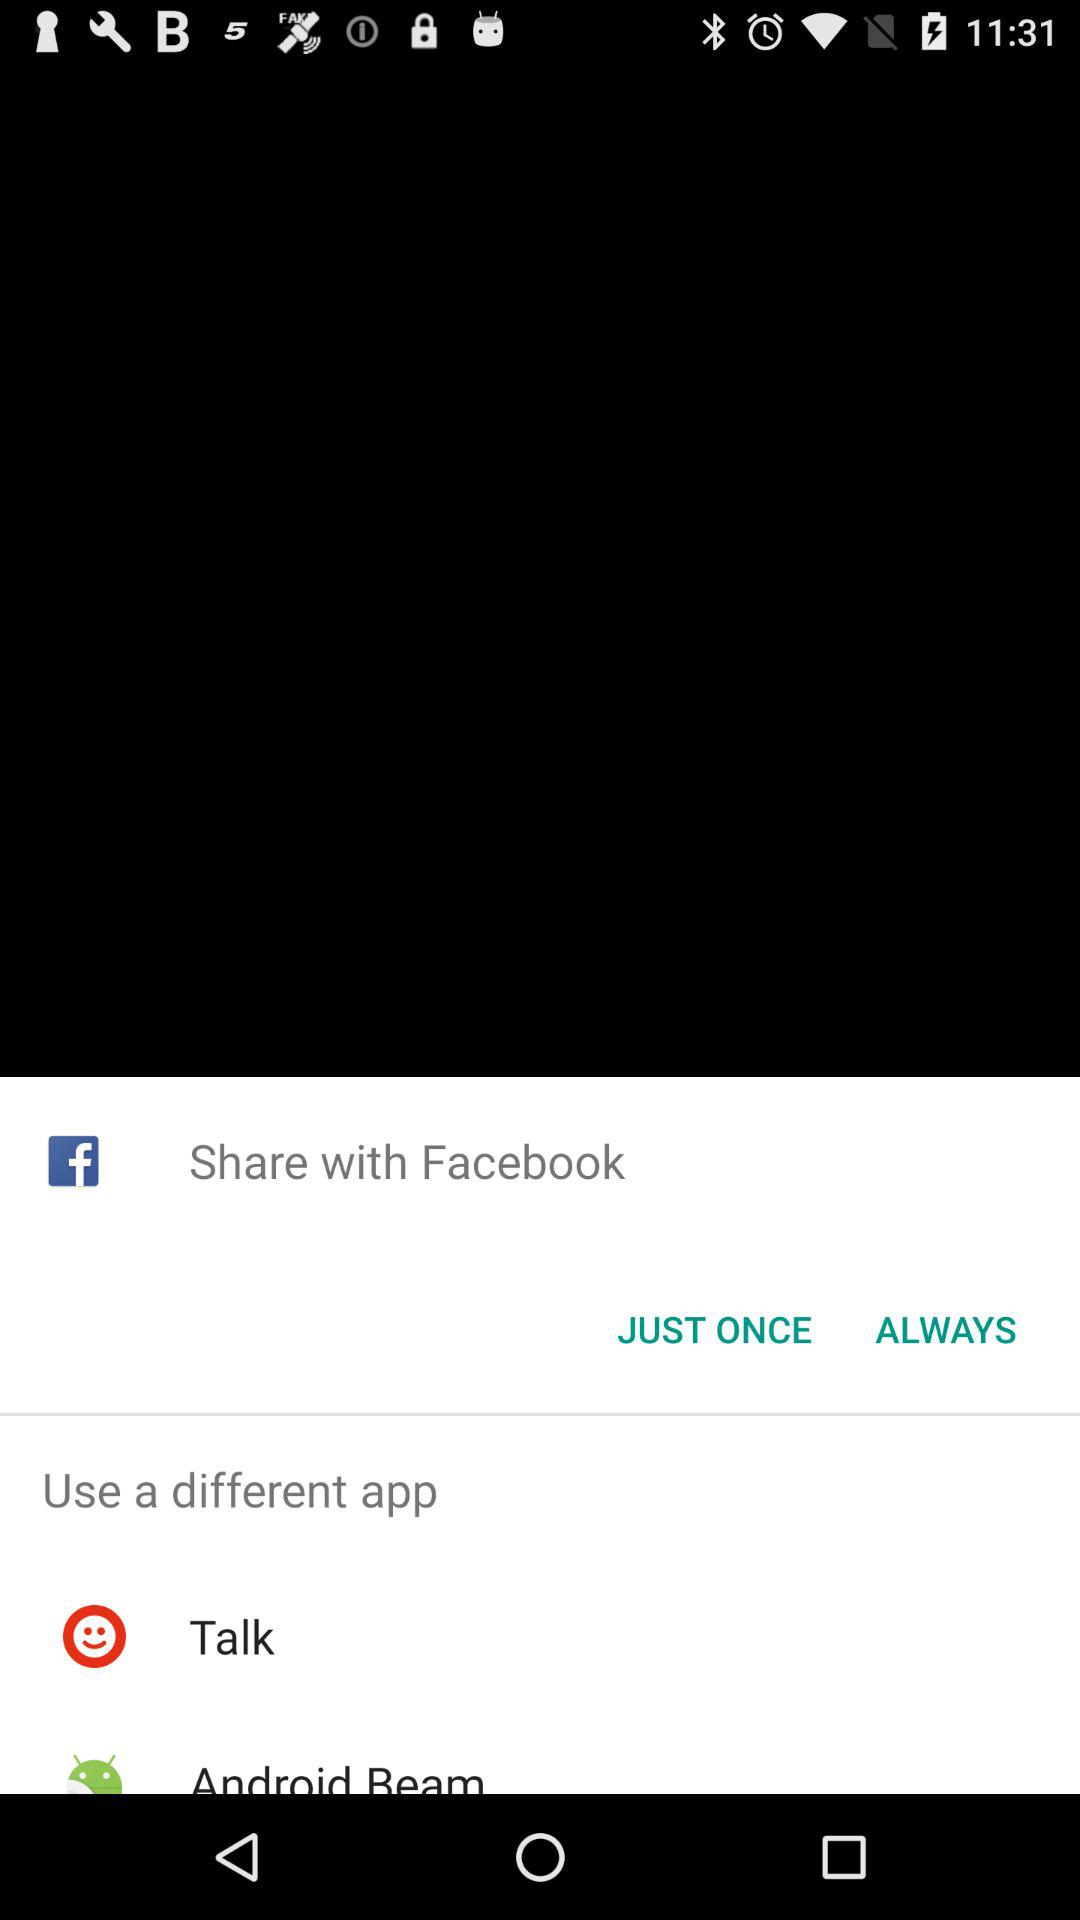Who is this application powered by?
When the provided information is insufficient, respond with <no answer>. <no answer> 